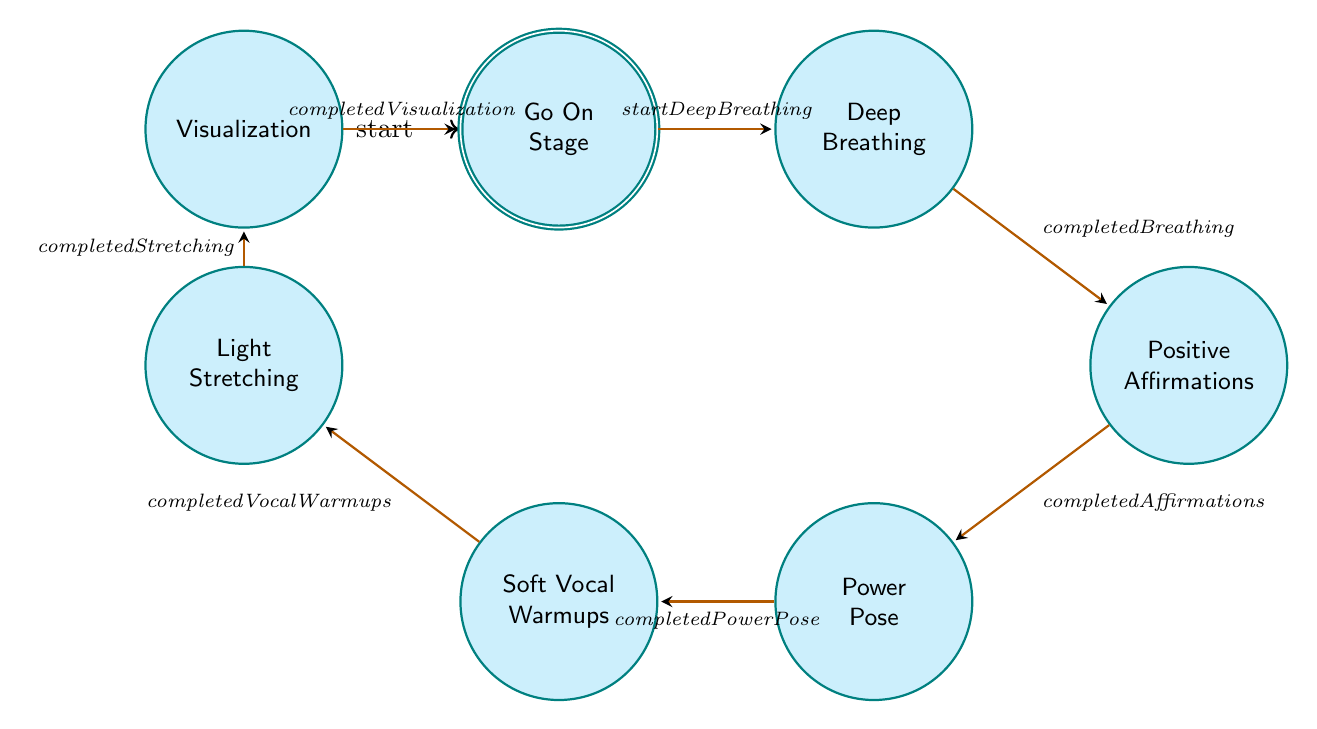What is the first state in the pre-show ritual? The diagram starts with the node labeled "Initial," which is the first state in the ritual process.
Answer: Initial How many states are there in total? Counting each state in the diagram, there are a total of seven states: Initial, Deep Breathing, Positive Affirmations, Power Pose, Soft Vocal Warmups, Light Stretching, Visualization, and Go On Stage.
Answer: Seven What transition occurs after completing deep breathing? After the "completed Breathing" event, the transition occurs to the state labeled "Positive Affirmations."
Answer: Positive Affirmations Which state involves striking a power pose? The state where one strikes a power pose is labeled "Power Pose." This state demonstrates that the performer should take this action as part of the ritual.
Answer: Power Pose What condition must be met to move from Positive Affirmations to Power Pose? The condition that must be satisfied to transition from "Positive Affirmations" to "Power Pose" is feeling "confident."
Answer: Confident What is the final state before going on stage? The final state before proceeding to "Go On Stage" is "Visualization," which is where the performer prepares mentally for a successful performance.
Answer: Visualization Which state requires light stretching exercises? The state that requires performing light stretching exercises is labeled "Light Stretching." This indicates that the performer should engage in these exercises as part of the pre-show preparation.
Answer: Light Stretching What are the last steps before a performer goes on stage? The last steps before going on stage include completing mental visualization, which makes the performer feel "mentally prepared," leading directly to the "Go On Stage" state.
Answer: Completed Visualization What action must be taken after soft vocal warmups? After completing soft vocal warmups, the action to proceed to is "Light Stretching" as indicated by the transition in the diagram from Soft Vocal Warmups.
Answer: Light Stretching 